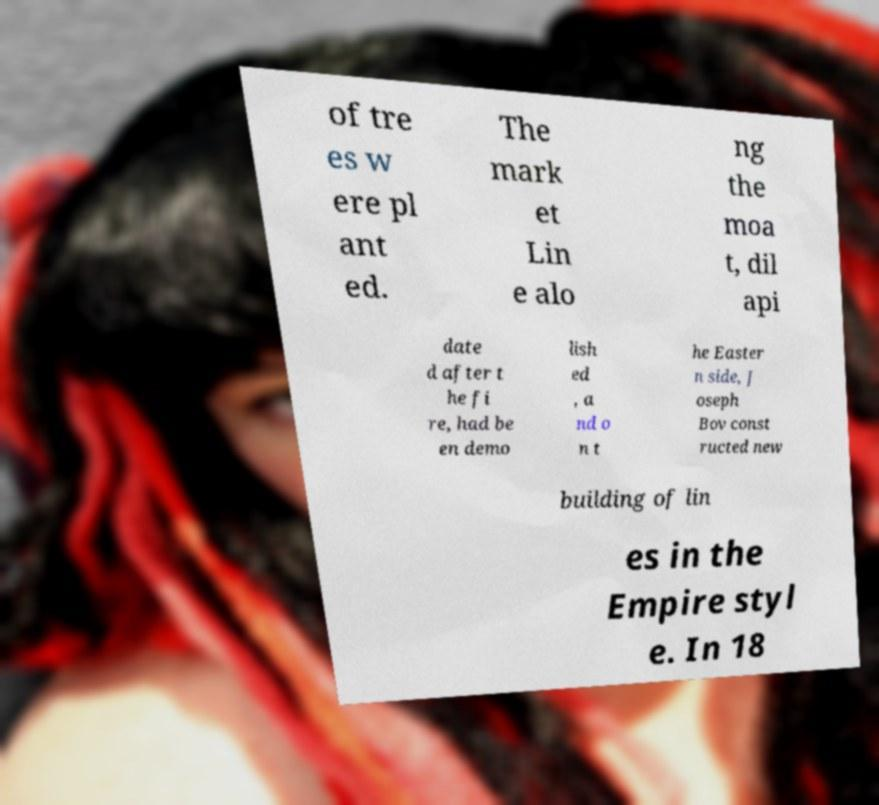I need the written content from this picture converted into text. Can you do that? of tre es w ere pl ant ed. The mark et Lin e alo ng the moa t, dil api date d after t he fi re, had be en demo lish ed , a nd o n t he Easter n side, J oseph Bov const ructed new building of lin es in the Empire styl e. In 18 